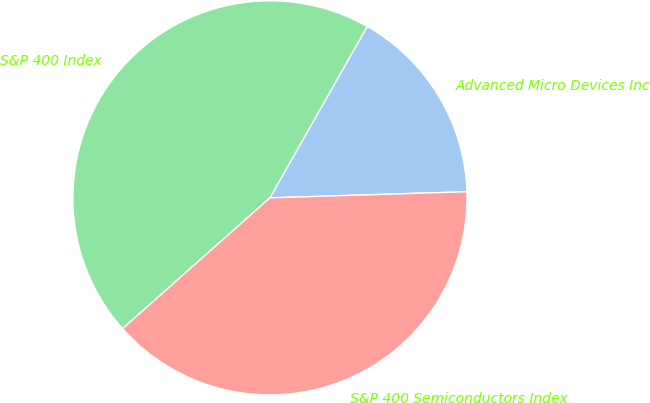Convert chart. <chart><loc_0><loc_0><loc_500><loc_500><pie_chart><fcel>Advanced Micro Devices Inc<fcel>S&P 400 Index<fcel>S&P 400 Semiconductors Index<nl><fcel>16.29%<fcel>44.77%<fcel>38.94%<nl></chart> 